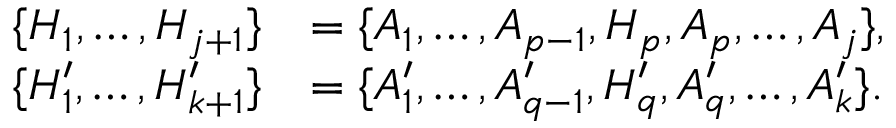Convert formula to latex. <formula><loc_0><loc_0><loc_500><loc_500>\begin{array} { r l } { \{ H _ { 1 } , \dots , H _ { j + 1 } \} } & { = \{ A _ { 1 } , \dots , A _ { p - 1 } , H _ { p } , A _ { p } , \dots , A _ { j } \} , } \\ { \{ H _ { 1 } ^ { \prime } , \dots , H _ { k + 1 } ^ { \prime } \} } & { = \{ A _ { 1 } ^ { \prime } , \dots , A _ { q - 1 } ^ { \prime } , H _ { q } ^ { \prime } , A _ { q } ^ { \prime } , \dots , A _ { k } ^ { \prime } \} . } \end{array}</formula> 